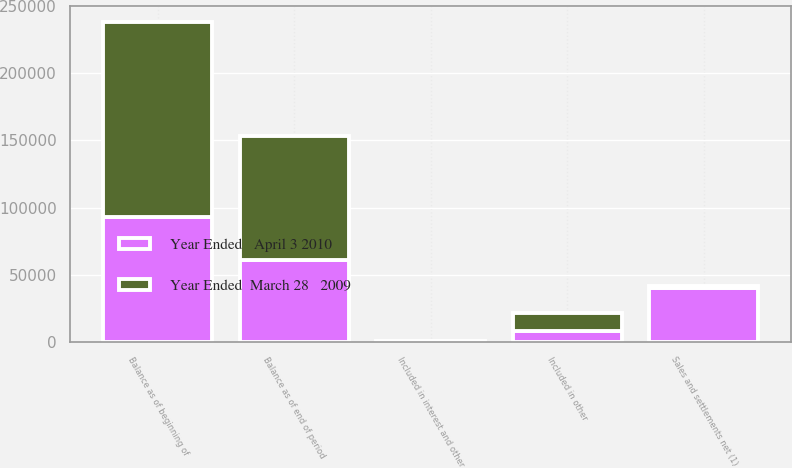<chart> <loc_0><loc_0><loc_500><loc_500><stacked_bar_chart><ecel><fcel>Balance as of beginning of<fcel>Included in interest and other<fcel>Included in other<fcel>Sales and settlements net (1)<fcel>Balance as of end of period<nl><fcel>Year Ended   April 3 2010<fcel>92736<fcel>262<fcel>8048<fcel>40250<fcel>60796<nl><fcel>Year Ended  March 28   2009<fcel>145388<fcel>170<fcel>13416<fcel>1400<fcel>92736<nl></chart> 